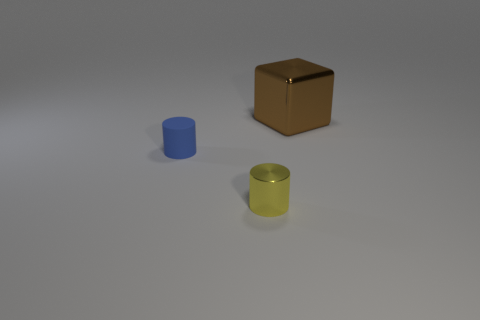Add 2 small blue objects. How many objects exist? 5 Subtract all blocks. How many objects are left? 2 Subtract 0 red blocks. How many objects are left? 3 Subtract all tiny cyan rubber cylinders. Subtract all blue cylinders. How many objects are left? 2 Add 3 tiny yellow objects. How many tiny yellow objects are left? 4 Add 3 large shiny objects. How many large shiny objects exist? 4 